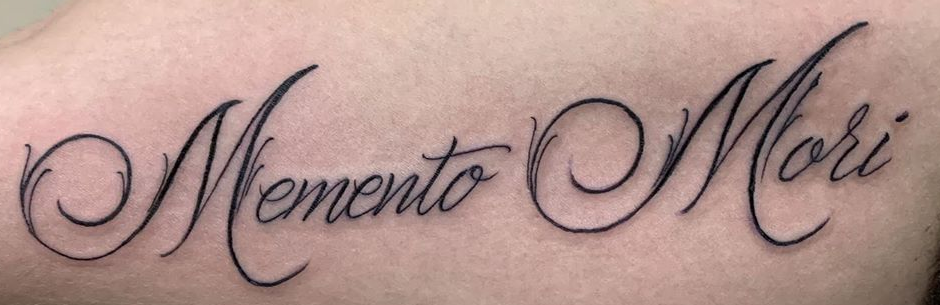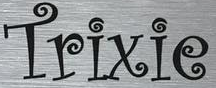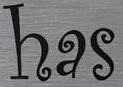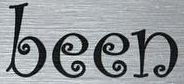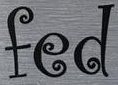Identify the words shown in these images in order, separated by a semicolon. MementoMori; Trixie; has; been; fed 